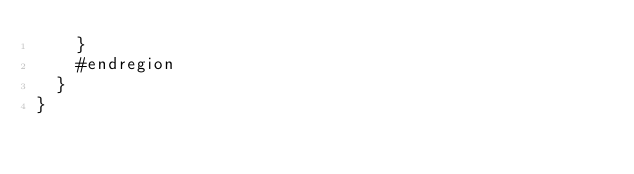<code> <loc_0><loc_0><loc_500><loc_500><_C#_>		}
		#endregion
	}
}

</code> 